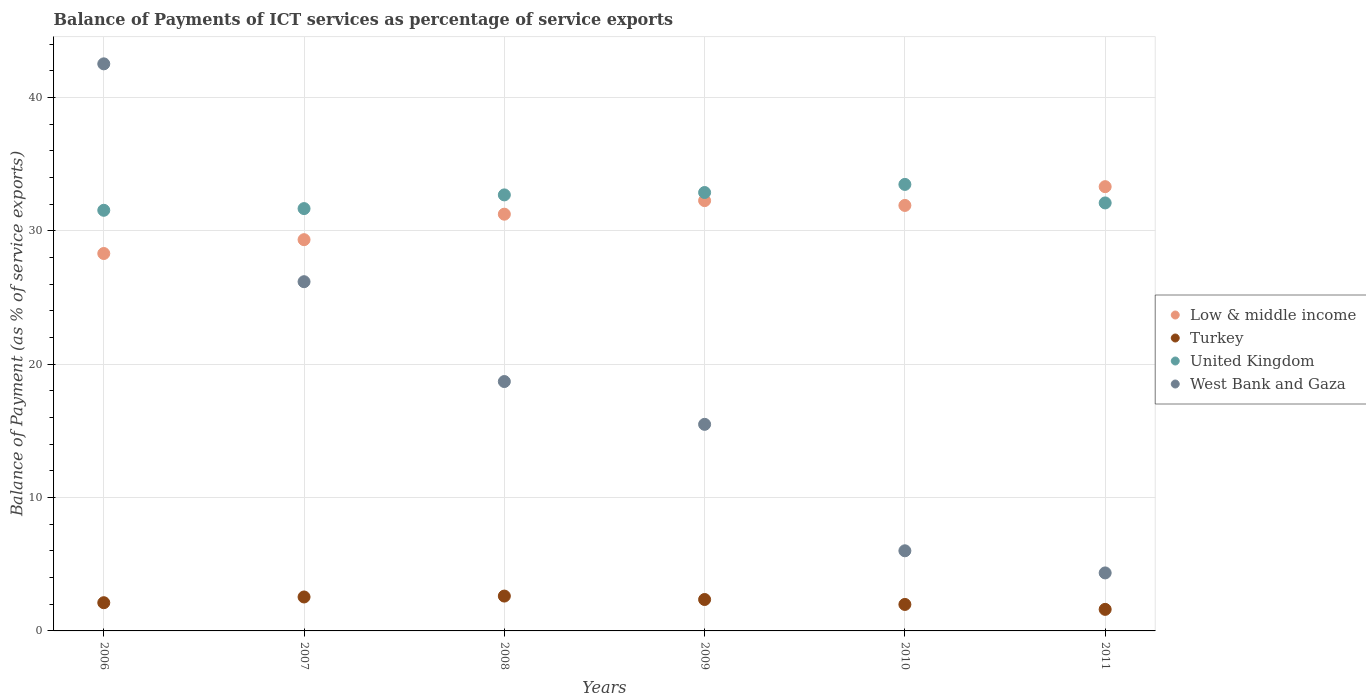Is the number of dotlines equal to the number of legend labels?
Ensure brevity in your answer.  Yes. What is the balance of payments of ICT services in Low & middle income in 2006?
Keep it short and to the point. 28.31. Across all years, what is the maximum balance of payments of ICT services in Turkey?
Your response must be concise. 2.61. Across all years, what is the minimum balance of payments of ICT services in West Bank and Gaza?
Provide a succinct answer. 4.35. In which year was the balance of payments of ICT services in Low & middle income minimum?
Give a very brief answer. 2006. What is the total balance of payments of ICT services in United Kingdom in the graph?
Provide a succinct answer. 194.4. What is the difference between the balance of payments of ICT services in United Kingdom in 2006 and that in 2008?
Offer a very short reply. -1.15. What is the difference between the balance of payments of ICT services in West Bank and Gaza in 2011 and the balance of payments of ICT services in Low & middle income in 2010?
Ensure brevity in your answer.  -27.56. What is the average balance of payments of ICT services in Low & middle income per year?
Provide a short and direct response. 31.07. In the year 2007, what is the difference between the balance of payments of ICT services in Turkey and balance of payments of ICT services in West Bank and Gaza?
Offer a very short reply. -23.65. What is the ratio of the balance of payments of ICT services in United Kingdom in 2010 to that in 2011?
Make the answer very short. 1.04. Is the balance of payments of ICT services in Low & middle income in 2010 less than that in 2011?
Provide a succinct answer. Yes. Is the difference between the balance of payments of ICT services in Turkey in 2008 and 2011 greater than the difference between the balance of payments of ICT services in West Bank and Gaza in 2008 and 2011?
Provide a short and direct response. No. What is the difference between the highest and the second highest balance of payments of ICT services in United Kingdom?
Ensure brevity in your answer.  0.61. What is the difference between the highest and the lowest balance of payments of ICT services in United Kingdom?
Provide a short and direct response. 1.94. Is it the case that in every year, the sum of the balance of payments of ICT services in United Kingdom and balance of payments of ICT services in Low & middle income  is greater than the sum of balance of payments of ICT services in West Bank and Gaza and balance of payments of ICT services in Turkey?
Your response must be concise. Yes. Is it the case that in every year, the sum of the balance of payments of ICT services in West Bank and Gaza and balance of payments of ICT services in Turkey  is greater than the balance of payments of ICT services in Low & middle income?
Make the answer very short. No. Is the balance of payments of ICT services in West Bank and Gaza strictly greater than the balance of payments of ICT services in Low & middle income over the years?
Give a very brief answer. No. How many dotlines are there?
Provide a succinct answer. 4. What is the difference between two consecutive major ticks on the Y-axis?
Offer a very short reply. 10. Are the values on the major ticks of Y-axis written in scientific E-notation?
Your answer should be very brief. No. Does the graph contain any zero values?
Offer a terse response. No. Does the graph contain grids?
Make the answer very short. Yes. Where does the legend appear in the graph?
Your answer should be compact. Center right. How many legend labels are there?
Ensure brevity in your answer.  4. How are the legend labels stacked?
Offer a very short reply. Vertical. What is the title of the graph?
Your response must be concise. Balance of Payments of ICT services as percentage of service exports. What is the label or title of the Y-axis?
Offer a very short reply. Balance of Payment (as % of service exports). What is the Balance of Payment (as % of service exports) of Low & middle income in 2006?
Provide a succinct answer. 28.31. What is the Balance of Payment (as % of service exports) in Turkey in 2006?
Your answer should be very brief. 2.12. What is the Balance of Payment (as % of service exports) of United Kingdom in 2006?
Provide a succinct answer. 31.55. What is the Balance of Payment (as % of service exports) in West Bank and Gaza in 2006?
Provide a short and direct response. 42.53. What is the Balance of Payment (as % of service exports) in Low & middle income in 2007?
Your answer should be compact. 29.34. What is the Balance of Payment (as % of service exports) in Turkey in 2007?
Provide a succinct answer. 2.55. What is the Balance of Payment (as % of service exports) of United Kingdom in 2007?
Give a very brief answer. 31.68. What is the Balance of Payment (as % of service exports) of West Bank and Gaza in 2007?
Give a very brief answer. 26.19. What is the Balance of Payment (as % of service exports) in Low & middle income in 2008?
Your answer should be very brief. 31.26. What is the Balance of Payment (as % of service exports) in Turkey in 2008?
Make the answer very short. 2.61. What is the Balance of Payment (as % of service exports) in United Kingdom in 2008?
Make the answer very short. 32.7. What is the Balance of Payment (as % of service exports) in West Bank and Gaza in 2008?
Make the answer very short. 18.7. What is the Balance of Payment (as % of service exports) in Low & middle income in 2009?
Offer a terse response. 32.27. What is the Balance of Payment (as % of service exports) in Turkey in 2009?
Keep it short and to the point. 2.36. What is the Balance of Payment (as % of service exports) in United Kingdom in 2009?
Your answer should be very brief. 32.88. What is the Balance of Payment (as % of service exports) of West Bank and Gaza in 2009?
Ensure brevity in your answer.  15.49. What is the Balance of Payment (as % of service exports) of Low & middle income in 2010?
Offer a very short reply. 31.91. What is the Balance of Payment (as % of service exports) of Turkey in 2010?
Give a very brief answer. 1.99. What is the Balance of Payment (as % of service exports) of United Kingdom in 2010?
Provide a succinct answer. 33.49. What is the Balance of Payment (as % of service exports) of West Bank and Gaza in 2010?
Your response must be concise. 6.01. What is the Balance of Payment (as % of service exports) in Low & middle income in 2011?
Provide a short and direct response. 33.32. What is the Balance of Payment (as % of service exports) in Turkey in 2011?
Ensure brevity in your answer.  1.62. What is the Balance of Payment (as % of service exports) of United Kingdom in 2011?
Provide a short and direct response. 32.1. What is the Balance of Payment (as % of service exports) of West Bank and Gaza in 2011?
Keep it short and to the point. 4.35. Across all years, what is the maximum Balance of Payment (as % of service exports) in Low & middle income?
Make the answer very short. 33.32. Across all years, what is the maximum Balance of Payment (as % of service exports) in Turkey?
Your answer should be very brief. 2.61. Across all years, what is the maximum Balance of Payment (as % of service exports) in United Kingdom?
Your answer should be compact. 33.49. Across all years, what is the maximum Balance of Payment (as % of service exports) in West Bank and Gaza?
Make the answer very short. 42.53. Across all years, what is the minimum Balance of Payment (as % of service exports) of Low & middle income?
Your answer should be very brief. 28.31. Across all years, what is the minimum Balance of Payment (as % of service exports) of Turkey?
Provide a short and direct response. 1.62. Across all years, what is the minimum Balance of Payment (as % of service exports) in United Kingdom?
Your response must be concise. 31.55. Across all years, what is the minimum Balance of Payment (as % of service exports) of West Bank and Gaza?
Offer a terse response. 4.35. What is the total Balance of Payment (as % of service exports) of Low & middle income in the graph?
Your response must be concise. 186.41. What is the total Balance of Payment (as % of service exports) in Turkey in the graph?
Your answer should be compact. 13.24. What is the total Balance of Payment (as % of service exports) in United Kingdom in the graph?
Offer a terse response. 194.4. What is the total Balance of Payment (as % of service exports) in West Bank and Gaza in the graph?
Your response must be concise. 113.28. What is the difference between the Balance of Payment (as % of service exports) of Low & middle income in 2006 and that in 2007?
Provide a short and direct response. -1.04. What is the difference between the Balance of Payment (as % of service exports) of Turkey in 2006 and that in 2007?
Ensure brevity in your answer.  -0.43. What is the difference between the Balance of Payment (as % of service exports) in United Kingdom in 2006 and that in 2007?
Offer a terse response. -0.13. What is the difference between the Balance of Payment (as % of service exports) in West Bank and Gaza in 2006 and that in 2007?
Offer a terse response. 16.34. What is the difference between the Balance of Payment (as % of service exports) of Low & middle income in 2006 and that in 2008?
Provide a short and direct response. -2.95. What is the difference between the Balance of Payment (as % of service exports) of Turkey in 2006 and that in 2008?
Your answer should be very brief. -0.5. What is the difference between the Balance of Payment (as % of service exports) of United Kingdom in 2006 and that in 2008?
Give a very brief answer. -1.16. What is the difference between the Balance of Payment (as % of service exports) of West Bank and Gaza in 2006 and that in 2008?
Your response must be concise. 23.83. What is the difference between the Balance of Payment (as % of service exports) in Low & middle income in 2006 and that in 2009?
Provide a short and direct response. -3.97. What is the difference between the Balance of Payment (as % of service exports) in Turkey in 2006 and that in 2009?
Your answer should be compact. -0.24. What is the difference between the Balance of Payment (as % of service exports) of United Kingdom in 2006 and that in 2009?
Offer a very short reply. -1.33. What is the difference between the Balance of Payment (as % of service exports) in West Bank and Gaza in 2006 and that in 2009?
Your response must be concise. 27.04. What is the difference between the Balance of Payment (as % of service exports) in Low & middle income in 2006 and that in 2010?
Provide a succinct answer. -3.61. What is the difference between the Balance of Payment (as % of service exports) in Turkey in 2006 and that in 2010?
Ensure brevity in your answer.  0.13. What is the difference between the Balance of Payment (as % of service exports) in United Kingdom in 2006 and that in 2010?
Your answer should be very brief. -1.94. What is the difference between the Balance of Payment (as % of service exports) of West Bank and Gaza in 2006 and that in 2010?
Your response must be concise. 36.52. What is the difference between the Balance of Payment (as % of service exports) in Low & middle income in 2006 and that in 2011?
Offer a very short reply. -5.01. What is the difference between the Balance of Payment (as % of service exports) in Turkey in 2006 and that in 2011?
Your response must be concise. 0.5. What is the difference between the Balance of Payment (as % of service exports) in United Kingdom in 2006 and that in 2011?
Keep it short and to the point. -0.55. What is the difference between the Balance of Payment (as % of service exports) in West Bank and Gaza in 2006 and that in 2011?
Keep it short and to the point. 38.18. What is the difference between the Balance of Payment (as % of service exports) in Low & middle income in 2007 and that in 2008?
Offer a terse response. -1.91. What is the difference between the Balance of Payment (as % of service exports) of Turkey in 2007 and that in 2008?
Keep it short and to the point. -0.07. What is the difference between the Balance of Payment (as % of service exports) in United Kingdom in 2007 and that in 2008?
Provide a succinct answer. -1.03. What is the difference between the Balance of Payment (as % of service exports) of West Bank and Gaza in 2007 and that in 2008?
Provide a succinct answer. 7.49. What is the difference between the Balance of Payment (as % of service exports) in Low & middle income in 2007 and that in 2009?
Make the answer very short. -2.93. What is the difference between the Balance of Payment (as % of service exports) of Turkey in 2007 and that in 2009?
Ensure brevity in your answer.  0.19. What is the difference between the Balance of Payment (as % of service exports) of United Kingdom in 2007 and that in 2009?
Your answer should be very brief. -1.21. What is the difference between the Balance of Payment (as % of service exports) in West Bank and Gaza in 2007 and that in 2009?
Provide a short and direct response. 10.7. What is the difference between the Balance of Payment (as % of service exports) of Low & middle income in 2007 and that in 2010?
Ensure brevity in your answer.  -2.57. What is the difference between the Balance of Payment (as % of service exports) of Turkey in 2007 and that in 2010?
Your answer should be very brief. 0.56. What is the difference between the Balance of Payment (as % of service exports) of United Kingdom in 2007 and that in 2010?
Your response must be concise. -1.81. What is the difference between the Balance of Payment (as % of service exports) in West Bank and Gaza in 2007 and that in 2010?
Your response must be concise. 20.18. What is the difference between the Balance of Payment (as % of service exports) of Low & middle income in 2007 and that in 2011?
Your answer should be compact. -3.98. What is the difference between the Balance of Payment (as % of service exports) in Turkey in 2007 and that in 2011?
Offer a very short reply. 0.93. What is the difference between the Balance of Payment (as % of service exports) of United Kingdom in 2007 and that in 2011?
Ensure brevity in your answer.  -0.42. What is the difference between the Balance of Payment (as % of service exports) in West Bank and Gaza in 2007 and that in 2011?
Provide a short and direct response. 21.84. What is the difference between the Balance of Payment (as % of service exports) in Low & middle income in 2008 and that in 2009?
Your answer should be very brief. -1.02. What is the difference between the Balance of Payment (as % of service exports) in Turkey in 2008 and that in 2009?
Offer a very short reply. 0.26. What is the difference between the Balance of Payment (as % of service exports) in United Kingdom in 2008 and that in 2009?
Offer a very short reply. -0.18. What is the difference between the Balance of Payment (as % of service exports) in West Bank and Gaza in 2008 and that in 2009?
Your answer should be compact. 3.21. What is the difference between the Balance of Payment (as % of service exports) in Low & middle income in 2008 and that in 2010?
Provide a short and direct response. -0.66. What is the difference between the Balance of Payment (as % of service exports) of Turkey in 2008 and that in 2010?
Your answer should be compact. 0.63. What is the difference between the Balance of Payment (as % of service exports) in United Kingdom in 2008 and that in 2010?
Offer a terse response. -0.79. What is the difference between the Balance of Payment (as % of service exports) in West Bank and Gaza in 2008 and that in 2010?
Make the answer very short. 12.69. What is the difference between the Balance of Payment (as % of service exports) of Low & middle income in 2008 and that in 2011?
Make the answer very short. -2.06. What is the difference between the Balance of Payment (as % of service exports) in Turkey in 2008 and that in 2011?
Keep it short and to the point. 1. What is the difference between the Balance of Payment (as % of service exports) of United Kingdom in 2008 and that in 2011?
Provide a succinct answer. 0.6. What is the difference between the Balance of Payment (as % of service exports) in West Bank and Gaza in 2008 and that in 2011?
Your response must be concise. 14.35. What is the difference between the Balance of Payment (as % of service exports) of Low & middle income in 2009 and that in 2010?
Keep it short and to the point. 0.36. What is the difference between the Balance of Payment (as % of service exports) in Turkey in 2009 and that in 2010?
Ensure brevity in your answer.  0.37. What is the difference between the Balance of Payment (as % of service exports) of United Kingdom in 2009 and that in 2010?
Offer a terse response. -0.61. What is the difference between the Balance of Payment (as % of service exports) of West Bank and Gaza in 2009 and that in 2010?
Provide a succinct answer. 9.48. What is the difference between the Balance of Payment (as % of service exports) of Low & middle income in 2009 and that in 2011?
Your answer should be very brief. -1.05. What is the difference between the Balance of Payment (as % of service exports) in Turkey in 2009 and that in 2011?
Provide a short and direct response. 0.74. What is the difference between the Balance of Payment (as % of service exports) in United Kingdom in 2009 and that in 2011?
Provide a succinct answer. 0.78. What is the difference between the Balance of Payment (as % of service exports) in West Bank and Gaza in 2009 and that in 2011?
Offer a very short reply. 11.14. What is the difference between the Balance of Payment (as % of service exports) in Low & middle income in 2010 and that in 2011?
Your answer should be compact. -1.41. What is the difference between the Balance of Payment (as % of service exports) in Turkey in 2010 and that in 2011?
Your answer should be very brief. 0.37. What is the difference between the Balance of Payment (as % of service exports) of United Kingdom in 2010 and that in 2011?
Ensure brevity in your answer.  1.39. What is the difference between the Balance of Payment (as % of service exports) in West Bank and Gaza in 2010 and that in 2011?
Provide a succinct answer. 1.66. What is the difference between the Balance of Payment (as % of service exports) in Low & middle income in 2006 and the Balance of Payment (as % of service exports) in Turkey in 2007?
Provide a short and direct response. 25.76. What is the difference between the Balance of Payment (as % of service exports) of Low & middle income in 2006 and the Balance of Payment (as % of service exports) of United Kingdom in 2007?
Provide a succinct answer. -3.37. What is the difference between the Balance of Payment (as % of service exports) of Low & middle income in 2006 and the Balance of Payment (as % of service exports) of West Bank and Gaza in 2007?
Your response must be concise. 2.11. What is the difference between the Balance of Payment (as % of service exports) in Turkey in 2006 and the Balance of Payment (as % of service exports) in United Kingdom in 2007?
Make the answer very short. -29.56. What is the difference between the Balance of Payment (as % of service exports) of Turkey in 2006 and the Balance of Payment (as % of service exports) of West Bank and Gaza in 2007?
Your answer should be very brief. -24.08. What is the difference between the Balance of Payment (as % of service exports) of United Kingdom in 2006 and the Balance of Payment (as % of service exports) of West Bank and Gaza in 2007?
Your response must be concise. 5.36. What is the difference between the Balance of Payment (as % of service exports) in Low & middle income in 2006 and the Balance of Payment (as % of service exports) in Turkey in 2008?
Your answer should be compact. 25.69. What is the difference between the Balance of Payment (as % of service exports) of Low & middle income in 2006 and the Balance of Payment (as % of service exports) of United Kingdom in 2008?
Your answer should be very brief. -4.4. What is the difference between the Balance of Payment (as % of service exports) of Low & middle income in 2006 and the Balance of Payment (as % of service exports) of West Bank and Gaza in 2008?
Provide a short and direct response. 9.6. What is the difference between the Balance of Payment (as % of service exports) in Turkey in 2006 and the Balance of Payment (as % of service exports) in United Kingdom in 2008?
Provide a succinct answer. -30.59. What is the difference between the Balance of Payment (as % of service exports) in Turkey in 2006 and the Balance of Payment (as % of service exports) in West Bank and Gaza in 2008?
Offer a terse response. -16.59. What is the difference between the Balance of Payment (as % of service exports) in United Kingdom in 2006 and the Balance of Payment (as % of service exports) in West Bank and Gaza in 2008?
Give a very brief answer. 12.84. What is the difference between the Balance of Payment (as % of service exports) of Low & middle income in 2006 and the Balance of Payment (as % of service exports) of Turkey in 2009?
Give a very brief answer. 25.95. What is the difference between the Balance of Payment (as % of service exports) of Low & middle income in 2006 and the Balance of Payment (as % of service exports) of United Kingdom in 2009?
Make the answer very short. -4.57. What is the difference between the Balance of Payment (as % of service exports) in Low & middle income in 2006 and the Balance of Payment (as % of service exports) in West Bank and Gaza in 2009?
Provide a succinct answer. 12.81. What is the difference between the Balance of Payment (as % of service exports) in Turkey in 2006 and the Balance of Payment (as % of service exports) in United Kingdom in 2009?
Offer a very short reply. -30.77. What is the difference between the Balance of Payment (as % of service exports) in Turkey in 2006 and the Balance of Payment (as % of service exports) in West Bank and Gaza in 2009?
Keep it short and to the point. -13.38. What is the difference between the Balance of Payment (as % of service exports) of United Kingdom in 2006 and the Balance of Payment (as % of service exports) of West Bank and Gaza in 2009?
Give a very brief answer. 16.05. What is the difference between the Balance of Payment (as % of service exports) of Low & middle income in 2006 and the Balance of Payment (as % of service exports) of Turkey in 2010?
Make the answer very short. 26.32. What is the difference between the Balance of Payment (as % of service exports) of Low & middle income in 2006 and the Balance of Payment (as % of service exports) of United Kingdom in 2010?
Give a very brief answer. -5.18. What is the difference between the Balance of Payment (as % of service exports) of Low & middle income in 2006 and the Balance of Payment (as % of service exports) of West Bank and Gaza in 2010?
Ensure brevity in your answer.  22.3. What is the difference between the Balance of Payment (as % of service exports) of Turkey in 2006 and the Balance of Payment (as % of service exports) of United Kingdom in 2010?
Your answer should be very brief. -31.37. What is the difference between the Balance of Payment (as % of service exports) in Turkey in 2006 and the Balance of Payment (as % of service exports) in West Bank and Gaza in 2010?
Offer a terse response. -3.89. What is the difference between the Balance of Payment (as % of service exports) in United Kingdom in 2006 and the Balance of Payment (as % of service exports) in West Bank and Gaza in 2010?
Give a very brief answer. 25.54. What is the difference between the Balance of Payment (as % of service exports) of Low & middle income in 2006 and the Balance of Payment (as % of service exports) of Turkey in 2011?
Keep it short and to the point. 26.69. What is the difference between the Balance of Payment (as % of service exports) of Low & middle income in 2006 and the Balance of Payment (as % of service exports) of United Kingdom in 2011?
Your answer should be compact. -3.79. What is the difference between the Balance of Payment (as % of service exports) of Low & middle income in 2006 and the Balance of Payment (as % of service exports) of West Bank and Gaza in 2011?
Keep it short and to the point. 23.96. What is the difference between the Balance of Payment (as % of service exports) in Turkey in 2006 and the Balance of Payment (as % of service exports) in United Kingdom in 2011?
Make the answer very short. -29.98. What is the difference between the Balance of Payment (as % of service exports) in Turkey in 2006 and the Balance of Payment (as % of service exports) in West Bank and Gaza in 2011?
Keep it short and to the point. -2.23. What is the difference between the Balance of Payment (as % of service exports) in United Kingdom in 2006 and the Balance of Payment (as % of service exports) in West Bank and Gaza in 2011?
Offer a terse response. 27.2. What is the difference between the Balance of Payment (as % of service exports) of Low & middle income in 2007 and the Balance of Payment (as % of service exports) of Turkey in 2008?
Offer a very short reply. 26.73. What is the difference between the Balance of Payment (as % of service exports) of Low & middle income in 2007 and the Balance of Payment (as % of service exports) of United Kingdom in 2008?
Offer a terse response. -3.36. What is the difference between the Balance of Payment (as % of service exports) in Low & middle income in 2007 and the Balance of Payment (as % of service exports) in West Bank and Gaza in 2008?
Give a very brief answer. 10.64. What is the difference between the Balance of Payment (as % of service exports) of Turkey in 2007 and the Balance of Payment (as % of service exports) of United Kingdom in 2008?
Ensure brevity in your answer.  -30.16. What is the difference between the Balance of Payment (as % of service exports) of Turkey in 2007 and the Balance of Payment (as % of service exports) of West Bank and Gaza in 2008?
Provide a short and direct response. -16.16. What is the difference between the Balance of Payment (as % of service exports) in United Kingdom in 2007 and the Balance of Payment (as % of service exports) in West Bank and Gaza in 2008?
Make the answer very short. 12.97. What is the difference between the Balance of Payment (as % of service exports) of Low & middle income in 2007 and the Balance of Payment (as % of service exports) of Turkey in 2009?
Offer a very short reply. 26.99. What is the difference between the Balance of Payment (as % of service exports) of Low & middle income in 2007 and the Balance of Payment (as % of service exports) of United Kingdom in 2009?
Your answer should be very brief. -3.54. What is the difference between the Balance of Payment (as % of service exports) in Low & middle income in 2007 and the Balance of Payment (as % of service exports) in West Bank and Gaza in 2009?
Your response must be concise. 13.85. What is the difference between the Balance of Payment (as % of service exports) in Turkey in 2007 and the Balance of Payment (as % of service exports) in United Kingdom in 2009?
Your answer should be very brief. -30.34. What is the difference between the Balance of Payment (as % of service exports) in Turkey in 2007 and the Balance of Payment (as % of service exports) in West Bank and Gaza in 2009?
Your answer should be very brief. -12.95. What is the difference between the Balance of Payment (as % of service exports) in United Kingdom in 2007 and the Balance of Payment (as % of service exports) in West Bank and Gaza in 2009?
Offer a very short reply. 16.18. What is the difference between the Balance of Payment (as % of service exports) in Low & middle income in 2007 and the Balance of Payment (as % of service exports) in Turkey in 2010?
Offer a terse response. 27.36. What is the difference between the Balance of Payment (as % of service exports) of Low & middle income in 2007 and the Balance of Payment (as % of service exports) of United Kingdom in 2010?
Ensure brevity in your answer.  -4.14. What is the difference between the Balance of Payment (as % of service exports) of Low & middle income in 2007 and the Balance of Payment (as % of service exports) of West Bank and Gaza in 2010?
Offer a terse response. 23.33. What is the difference between the Balance of Payment (as % of service exports) of Turkey in 2007 and the Balance of Payment (as % of service exports) of United Kingdom in 2010?
Keep it short and to the point. -30.94. What is the difference between the Balance of Payment (as % of service exports) in Turkey in 2007 and the Balance of Payment (as % of service exports) in West Bank and Gaza in 2010?
Your answer should be very brief. -3.46. What is the difference between the Balance of Payment (as % of service exports) in United Kingdom in 2007 and the Balance of Payment (as % of service exports) in West Bank and Gaza in 2010?
Your response must be concise. 25.67. What is the difference between the Balance of Payment (as % of service exports) of Low & middle income in 2007 and the Balance of Payment (as % of service exports) of Turkey in 2011?
Your answer should be very brief. 27.73. What is the difference between the Balance of Payment (as % of service exports) in Low & middle income in 2007 and the Balance of Payment (as % of service exports) in United Kingdom in 2011?
Offer a terse response. -2.76. What is the difference between the Balance of Payment (as % of service exports) of Low & middle income in 2007 and the Balance of Payment (as % of service exports) of West Bank and Gaza in 2011?
Your response must be concise. 24.99. What is the difference between the Balance of Payment (as % of service exports) in Turkey in 2007 and the Balance of Payment (as % of service exports) in United Kingdom in 2011?
Offer a very short reply. -29.55. What is the difference between the Balance of Payment (as % of service exports) of Turkey in 2007 and the Balance of Payment (as % of service exports) of West Bank and Gaza in 2011?
Make the answer very short. -1.8. What is the difference between the Balance of Payment (as % of service exports) in United Kingdom in 2007 and the Balance of Payment (as % of service exports) in West Bank and Gaza in 2011?
Keep it short and to the point. 27.33. What is the difference between the Balance of Payment (as % of service exports) of Low & middle income in 2008 and the Balance of Payment (as % of service exports) of Turkey in 2009?
Offer a terse response. 28.9. What is the difference between the Balance of Payment (as % of service exports) of Low & middle income in 2008 and the Balance of Payment (as % of service exports) of United Kingdom in 2009?
Offer a very short reply. -1.63. What is the difference between the Balance of Payment (as % of service exports) in Low & middle income in 2008 and the Balance of Payment (as % of service exports) in West Bank and Gaza in 2009?
Give a very brief answer. 15.76. What is the difference between the Balance of Payment (as % of service exports) in Turkey in 2008 and the Balance of Payment (as % of service exports) in United Kingdom in 2009?
Offer a very short reply. -30.27. What is the difference between the Balance of Payment (as % of service exports) in Turkey in 2008 and the Balance of Payment (as % of service exports) in West Bank and Gaza in 2009?
Offer a terse response. -12.88. What is the difference between the Balance of Payment (as % of service exports) in United Kingdom in 2008 and the Balance of Payment (as % of service exports) in West Bank and Gaza in 2009?
Offer a very short reply. 17.21. What is the difference between the Balance of Payment (as % of service exports) in Low & middle income in 2008 and the Balance of Payment (as % of service exports) in Turkey in 2010?
Keep it short and to the point. 29.27. What is the difference between the Balance of Payment (as % of service exports) in Low & middle income in 2008 and the Balance of Payment (as % of service exports) in United Kingdom in 2010?
Provide a short and direct response. -2.23. What is the difference between the Balance of Payment (as % of service exports) in Low & middle income in 2008 and the Balance of Payment (as % of service exports) in West Bank and Gaza in 2010?
Offer a very short reply. 25.25. What is the difference between the Balance of Payment (as % of service exports) in Turkey in 2008 and the Balance of Payment (as % of service exports) in United Kingdom in 2010?
Provide a short and direct response. -30.88. What is the difference between the Balance of Payment (as % of service exports) of Turkey in 2008 and the Balance of Payment (as % of service exports) of West Bank and Gaza in 2010?
Provide a short and direct response. -3.4. What is the difference between the Balance of Payment (as % of service exports) in United Kingdom in 2008 and the Balance of Payment (as % of service exports) in West Bank and Gaza in 2010?
Give a very brief answer. 26.69. What is the difference between the Balance of Payment (as % of service exports) of Low & middle income in 2008 and the Balance of Payment (as % of service exports) of Turkey in 2011?
Your answer should be compact. 29.64. What is the difference between the Balance of Payment (as % of service exports) in Low & middle income in 2008 and the Balance of Payment (as % of service exports) in United Kingdom in 2011?
Your answer should be very brief. -0.84. What is the difference between the Balance of Payment (as % of service exports) in Low & middle income in 2008 and the Balance of Payment (as % of service exports) in West Bank and Gaza in 2011?
Provide a short and direct response. 26.91. What is the difference between the Balance of Payment (as % of service exports) of Turkey in 2008 and the Balance of Payment (as % of service exports) of United Kingdom in 2011?
Offer a terse response. -29.49. What is the difference between the Balance of Payment (as % of service exports) in Turkey in 2008 and the Balance of Payment (as % of service exports) in West Bank and Gaza in 2011?
Offer a terse response. -1.74. What is the difference between the Balance of Payment (as % of service exports) in United Kingdom in 2008 and the Balance of Payment (as % of service exports) in West Bank and Gaza in 2011?
Make the answer very short. 28.35. What is the difference between the Balance of Payment (as % of service exports) in Low & middle income in 2009 and the Balance of Payment (as % of service exports) in Turkey in 2010?
Your answer should be compact. 30.29. What is the difference between the Balance of Payment (as % of service exports) of Low & middle income in 2009 and the Balance of Payment (as % of service exports) of United Kingdom in 2010?
Ensure brevity in your answer.  -1.22. What is the difference between the Balance of Payment (as % of service exports) in Low & middle income in 2009 and the Balance of Payment (as % of service exports) in West Bank and Gaza in 2010?
Ensure brevity in your answer.  26.26. What is the difference between the Balance of Payment (as % of service exports) in Turkey in 2009 and the Balance of Payment (as % of service exports) in United Kingdom in 2010?
Your answer should be compact. -31.13. What is the difference between the Balance of Payment (as % of service exports) in Turkey in 2009 and the Balance of Payment (as % of service exports) in West Bank and Gaza in 2010?
Keep it short and to the point. -3.65. What is the difference between the Balance of Payment (as % of service exports) in United Kingdom in 2009 and the Balance of Payment (as % of service exports) in West Bank and Gaza in 2010?
Keep it short and to the point. 26.87. What is the difference between the Balance of Payment (as % of service exports) of Low & middle income in 2009 and the Balance of Payment (as % of service exports) of Turkey in 2011?
Your answer should be compact. 30.66. What is the difference between the Balance of Payment (as % of service exports) in Low & middle income in 2009 and the Balance of Payment (as % of service exports) in United Kingdom in 2011?
Offer a very short reply. 0.17. What is the difference between the Balance of Payment (as % of service exports) of Low & middle income in 2009 and the Balance of Payment (as % of service exports) of West Bank and Gaza in 2011?
Ensure brevity in your answer.  27.92. What is the difference between the Balance of Payment (as % of service exports) in Turkey in 2009 and the Balance of Payment (as % of service exports) in United Kingdom in 2011?
Keep it short and to the point. -29.74. What is the difference between the Balance of Payment (as % of service exports) in Turkey in 2009 and the Balance of Payment (as % of service exports) in West Bank and Gaza in 2011?
Provide a succinct answer. -1.99. What is the difference between the Balance of Payment (as % of service exports) in United Kingdom in 2009 and the Balance of Payment (as % of service exports) in West Bank and Gaza in 2011?
Offer a terse response. 28.53. What is the difference between the Balance of Payment (as % of service exports) of Low & middle income in 2010 and the Balance of Payment (as % of service exports) of Turkey in 2011?
Your answer should be compact. 30.3. What is the difference between the Balance of Payment (as % of service exports) in Low & middle income in 2010 and the Balance of Payment (as % of service exports) in United Kingdom in 2011?
Your answer should be compact. -0.19. What is the difference between the Balance of Payment (as % of service exports) of Low & middle income in 2010 and the Balance of Payment (as % of service exports) of West Bank and Gaza in 2011?
Your response must be concise. 27.56. What is the difference between the Balance of Payment (as % of service exports) of Turkey in 2010 and the Balance of Payment (as % of service exports) of United Kingdom in 2011?
Offer a very short reply. -30.11. What is the difference between the Balance of Payment (as % of service exports) of Turkey in 2010 and the Balance of Payment (as % of service exports) of West Bank and Gaza in 2011?
Your answer should be very brief. -2.36. What is the difference between the Balance of Payment (as % of service exports) of United Kingdom in 2010 and the Balance of Payment (as % of service exports) of West Bank and Gaza in 2011?
Provide a succinct answer. 29.14. What is the average Balance of Payment (as % of service exports) in Low & middle income per year?
Your response must be concise. 31.07. What is the average Balance of Payment (as % of service exports) in Turkey per year?
Keep it short and to the point. 2.21. What is the average Balance of Payment (as % of service exports) in United Kingdom per year?
Give a very brief answer. 32.4. What is the average Balance of Payment (as % of service exports) in West Bank and Gaza per year?
Ensure brevity in your answer.  18.88. In the year 2006, what is the difference between the Balance of Payment (as % of service exports) of Low & middle income and Balance of Payment (as % of service exports) of Turkey?
Your response must be concise. 26.19. In the year 2006, what is the difference between the Balance of Payment (as % of service exports) in Low & middle income and Balance of Payment (as % of service exports) in United Kingdom?
Your answer should be compact. -3.24. In the year 2006, what is the difference between the Balance of Payment (as % of service exports) of Low & middle income and Balance of Payment (as % of service exports) of West Bank and Gaza?
Make the answer very short. -14.22. In the year 2006, what is the difference between the Balance of Payment (as % of service exports) in Turkey and Balance of Payment (as % of service exports) in United Kingdom?
Provide a succinct answer. -29.43. In the year 2006, what is the difference between the Balance of Payment (as % of service exports) in Turkey and Balance of Payment (as % of service exports) in West Bank and Gaza?
Provide a short and direct response. -40.42. In the year 2006, what is the difference between the Balance of Payment (as % of service exports) in United Kingdom and Balance of Payment (as % of service exports) in West Bank and Gaza?
Your answer should be very brief. -10.98. In the year 2007, what is the difference between the Balance of Payment (as % of service exports) in Low & middle income and Balance of Payment (as % of service exports) in Turkey?
Give a very brief answer. 26.8. In the year 2007, what is the difference between the Balance of Payment (as % of service exports) of Low & middle income and Balance of Payment (as % of service exports) of United Kingdom?
Offer a very short reply. -2.33. In the year 2007, what is the difference between the Balance of Payment (as % of service exports) in Low & middle income and Balance of Payment (as % of service exports) in West Bank and Gaza?
Your response must be concise. 3.15. In the year 2007, what is the difference between the Balance of Payment (as % of service exports) of Turkey and Balance of Payment (as % of service exports) of United Kingdom?
Provide a short and direct response. -29.13. In the year 2007, what is the difference between the Balance of Payment (as % of service exports) of Turkey and Balance of Payment (as % of service exports) of West Bank and Gaza?
Your answer should be compact. -23.65. In the year 2007, what is the difference between the Balance of Payment (as % of service exports) in United Kingdom and Balance of Payment (as % of service exports) in West Bank and Gaza?
Provide a succinct answer. 5.48. In the year 2008, what is the difference between the Balance of Payment (as % of service exports) of Low & middle income and Balance of Payment (as % of service exports) of Turkey?
Provide a succinct answer. 28.64. In the year 2008, what is the difference between the Balance of Payment (as % of service exports) of Low & middle income and Balance of Payment (as % of service exports) of United Kingdom?
Ensure brevity in your answer.  -1.45. In the year 2008, what is the difference between the Balance of Payment (as % of service exports) in Low & middle income and Balance of Payment (as % of service exports) in West Bank and Gaza?
Offer a very short reply. 12.55. In the year 2008, what is the difference between the Balance of Payment (as % of service exports) of Turkey and Balance of Payment (as % of service exports) of United Kingdom?
Make the answer very short. -30.09. In the year 2008, what is the difference between the Balance of Payment (as % of service exports) of Turkey and Balance of Payment (as % of service exports) of West Bank and Gaza?
Provide a succinct answer. -16.09. In the year 2008, what is the difference between the Balance of Payment (as % of service exports) of United Kingdom and Balance of Payment (as % of service exports) of West Bank and Gaza?
Your answer should be compact. 14. In the year 2009, what is the difference between the Balance of Payment (as % of service exports) in Low & middle income and Balance of Payment (as % of service exports) in Turkey?
Keep it short and to the point. 29.92. In the year 2009, what is the difference between the Balance of Payment (as % of service exports) of Low & middle income and Balance of Payment (as % of service exports) of United Kingdom?
Offer a terse response. -0.61. In the year 2009, what is the difference between the Balance of Payment (as % of service exports) in Low & middle income and Balance of Payment (as % of service exports) in West Bank and Gaza?
Keep it short and to the point. 16.78. In the year 2009, what is the difference between the Balance of Payment (as % of service exports) of Turkey and Balance of Payment (as % of service exports) of United Kingdom?
Offer a terse response. -30.52. In the year 2009, what is the difference between the Balance of Payment (as % of service exports) of Turkey and Balance of Payment (as % of service exports) of West Bank and Gaza?
Give a very brief answer. -13.14. In the year 2009, what is the difference between the Balance of Payment (as % of service exports) in United Kingdom and Balance of Payment (as % of service exports) in West Bank and Gaza?
Offer a very short reply. 17.39. In the year 2010, what is the difference between the Balance of Payment (as % of service exports) in Low & middle income and Balance of Payment (as % of service exports) in Turkey?
Offer a terse response. 29.93. In the year 2010, what is the difference between the Balance of Payment (as % of service exports) in Low & middle income and Balance of Payment (as % of service exports) in United Kingdom?
Provide a succinct answer. -1.58. In the year 2010, what is the difference between the Balance of Payment (as % of service exports) of Low & middle income and Balance of Payment (as % of service exports) of West Bank and Gaza?
Provide a succinct answer. 25.9. In the year 2010, what is the difference between the Balance of Payment (as % of service exports) in Turkey and Balance of Payment (as % of service exports) in United Kingdom?
Make the answer very short. -31.5. In the year 2010, what is the difference between the Balance of Payment (as % of service exports) in Turkey and Balance of Payment (as % of service exports) in West Bank and Gaza?
Give a very brief answer. -4.02. In the year 2010, what is the difference between the Balance of Payment (as % of service exports) of United Kingdom and Balance of Payment (as % of service exports) of West Bank and Gaza?
Your answer should be compact. 27.48. In the year 2011, what is the difference between the Balance of Payment (as % of service exports) of Low & middle income and Balance of Payment (as % of service exports) of Turkey?
Ensure brevity in your answer.  31.7. In the year 2011, what is the difference between the Balance of Payment (as % of service exports) in Low & middle income and Balance of Payment (as % of service exports) in United Kingdom?
Offer a terse response. 1.22. In the year 2011, what is the difference between the Balance of Payment (as % of service exports) of Low & middle income and Balance of Payment (as % of service exports) of West Bank and Gaza?
Your answer should be compact. 28.97. In the year 2011, what is the difference between the Balance of Payment (as % of service exports) in Turkey and Balance of Payment (as % of service exports) in United Kingdom?
Your answer should be compact. -30.48. In the year 2011, what is the difference between the Balance of Payment (as % of service exports) of Turkey and Balance of Payment (as % of service exports) of West Bank and Gaza?
Give a very brief answer. -2.73. In the year 2011, what is the difference between the Balance of Payment (as % of service exports) of United Kingdom and Balance of Payment (as % of service exports) of West Bank and Gaza?
Ensure brevity in your answer.  27.75. What is the ratio of the Balance of Payment (as % of service exports) in Low & middle income in 2006 to that in 2007?
Ensure brevity in your answer.  0.96. What is the ratio of the Balance of Payment (as % of service exports) of Turkey in 2006 to that in 2007?
Your answer should be compact. 0.83. What is the ratio of the Balance of Payment (as % of service exports) in West Bank and Gaza in 2006 to that in 2007?
Provide a succinct answer. 1.62. What is the ratio of the Balance of Payment (as % of service exports) of Low & middle income in 2006 to that in 2008?
Your answer should be compact. 0.91. What is the ratio of the Balance of Payment (as % of service exports) in Turkey in 2006 to that in 2008?
Make the answer very short. 0.81. What is the ratio of the Balance of Payment (as % of service exports) of United Kingdom in 2006 to that in 2008?
Your response must be concise. 0.96. What is the ratio of the Balance of Payment (as % of service exports) of West Bank and Gaza in 2006 to that in 2008?
Your response must be concise. 2.27. What is the ratio of the Balance of Payment (as % of service exports) of Low & middle income in 2006 to that in 2009?
Provide a short and direct response. 0.88. What is the ratio of the Balance of Payment (as % of service exports) of Turkey in 2006 to that in 2009?
Your response must be concise. 0.9. What is the ratio of the Balance of Payment (as % of service exports) in United Kingdom in 2006 to that in 2009?
Give a very brief answer. 0.96. What is the ratio of the Balance of Payment (as % of service exports) of West Bank and Gaza in 2006 to that in 2009?
Your answer should be compact. 2.75. What is the ratio of the Balance of Payment (as % of service exports) of Low & middle income in 2006 to that in 2010?
Your answer should be very brief. 0.89. What is the ratio of the Balance of Payment (as % of service exports) of Turkey in 2006 to that in 2010?
Offer a very short reply. 1.07. What is the ratio of the Balance of Payment (as % of service exports) of United Kingdom in 2006 to that in 2010?
Provide a succinct answer. 0.94. What is the ratio of the Balance of Payment (as % of service exports) of West Bank and Gaza in 2006 to that in 2010?
Offer a terse response. 7.08. What is the ratio of the Balance of Payment (as % of service exports) in Low & middle income in 2006 to that in 2011?
Give a very brief answer. 0.85. What is the ratio of the Balance of Payment (as % of service exports) in Turkey in 2006 to that in 2011?
Ensure brevity in your answer.  1.31. What is the ratio of the Balance of Payment (as % of service exports) in United Kingdom in 2006 to that in 2011?
Give a very brief answer. 0.98. What is the ratio of the Balance of Payment (as % of service exports) in West Bank and Gaza in 2006 to that in 2011?
Provide a succinct answer. 9.78. What is the ratio of the Balance of Payment (as % of service exports) of Low & middle income in 2007 to that in 2008?
Ensure brevity in your answer.  0.94. What is the ratio of the Balance of Payment (as % of service exports) of Turkey in 2007 to that in 2008?
Make the answer very short. 0.97. What is the ratio of the Balance of Payment (as % of service exports) of United Kingdom in 2007 to that in 2008?
Your answer should be very brief. 0.97. What is the ratio of the Balance of Payment (as % of service exports) in West Bank and Gaza in 2007 to that in 2008?
Make the answer very short. 1.4. What is the ratio of the Balance of Payment (as % of service exports) of Low & middle income in 2007 to that in 2009?
Your answer should be compact. 0.91. What is the ratio of the Balance of Payment (as % of service exports) in Turkey in 2007 to that in 2009?
Ensure brevity in your answer.  1.08. What is the ratio of the Balance of Payment (as % of service exports) of United Kingdom in 2007 to that in 2009?
Your answer should be very brief. 0.96. What is the ratio of the Balance of Payment (as % of service exports) of West Bank and Gaza in 2007 to that in 2009?
Your response must be concise. 1.69. What is the ratio of the Balance of Payment (as % of service exports) in Low & middle income in 2007 to that in 2010?
Give a very brief answer. 0.92. What is the ratio of the Balance of Payment (as % of service exports) in Turkey in 2007 to that in 2010?
Make the answer very short. 1.28. What is the ratio of the Balance of Payment (as % of service exports) in United Kingdom in 2007 to that in 2010?
Your answer should be very brief. 0.95. What is the ratio of the Balance of Payment (as % of service exports) of West Bank and Gaza in 2007 to that in 2010?
Your answer should be very brief. 4.36. What is the ratio of the Balance of Payment (as % of service exports) of Low & middle income in 2007 to that in 2011?
Provide a short and direct response. 0.88. What is the ratio of the Balance of Payment (as % of service exports) in Turkey in 2007 to that in 2011?
Offer a terse response. 1.58. What is the ratio of the Balance of Payment (as % of service exports) of West Bank and Gaza in 2007 to that in 2011?
Give a very brief answer. 6.02. What is the ratio of the Balance of Payment (as % of service exports) of Low & middle income in 2008 to that in 2009?
Give a very brief answer. 0.97. What is the ratio of the Balance of Payment (as % of service exports) in Turkey in 2008 to that in 2009?
Ensure brevity in your answer.  1.11. What is the ratio of the Balance of Payment (as % of service exports) in United Kingdom in 2008 to that in 2009?
Provide a succinct answer. 0.99. What is the ratio of the Balance of Payment (as % of service exports) in West Bank and Gaza in 2008 to that in 2009?
Your answer should be compact. 1.21. What is the ratio of the Balance of Payment (as % of service exports) of Low & middle income in 2008 to that in 2010?
Provide a succinct answer. 0.98. What is the ratio of the Balance of Payment (as % of service exports) of Turkey in 2008 to that in 2010?
Your response must be concise. 1.32. What is the ratio of the Balance of Payment (as % of service exports) in United Kingdom in 2008 to that in 2010?
Give a very brief answer. 0.98. What is the ratio of the Balance of Payment (as % of service exports) of West Bank and Gaza in 2008 to that in 2010?
Offer a terse response. 3.11. What is the ratio of the Balance of Payment (as % of service exports) in Low & middle income in 2008 to that in 2011?
Provide a succinct answer. 0.94. What is the ratio of the Balance of Payment (as % of service exports) of Turkey in 2008 to that in 2011?
Your answer should be compact. 1.62. What is the ratio of the Balance of Payment (as % of service exports) of United Kingdom in 2008 to that in 2011?
Provide a short and direct response. 1.02. What is the ratio of the Balance of Payment (as % of service exports) of West Bank and Gaza in 2008 to that in 2011?
Offer a terse response. 4.3. What is the ratio of the Balance of Payment (as % of service exports) of Low & middle income in 2009 to that in 2010?
Your answer should be very brief. 1.01. What is the ratio of the Balance of Payment (as % of service exports) of Turkey in 2009 to that in 2010?
Your response must be concise. 1.19. What is the ratio of the Balance of Payment (as % of service exports) in United Kingdom in 2009 to that in 2010?
Your answer should be very brief. 0.98. What is the ratio of the Balance of Payment (as % of service exports) in West Bank and Gaza in 2009 to that in 2010?
Ensure brevity in your answer.  2.58. What is the ratio of the Balance of Payment (as % of service exports) of Low & middle income in 2009 to that in 2011?
Provide a succinct answer. 0.97. What is the ratio of the Balance of Payment (as % of service exports) of Turkey in 2009 to that in 2011?
Offer a very short reply. 1.46. What is the ratio of the Balance of Payment (as % of service exports) in United Kingdom in 2009 to that in 2011?
Ensure brevity in your answer.  1.02. What is the ratio of the Balance of Payment (as % of service exports) in West Bank and Gaza in 2009 to that in 2011?
Your answer should be very brief. 3.56. What is the ratio of the Balance of Payment (as % of service exports) in Low & middle income in 2010 to that in 2011?
Give a very brief answer. 0.96. What is the ratio of the Balance of Payment (as % of service exports) of Turkey in 2010 to that in 2011?
Your answer should be very brief. 1.23. What is the ratio of the Balance of Payment (as % of service exports) in United Kingdom in 2010 to that in 2011?
Offer a very short reply. 1.04. What is the ratio of the Balance of Payment (as % of service exports) of West Bank and Gaza in 2010 to that in 2011?
Your answer should be very brief. 1.38. What is the difference between the highest and the second highest Balance of Payment (as % of service exports) of Low & middle income?
Keep it short and to the point. 1.05. What is the difference between the highest and the second highest Balance of Payment (as % of service exports) in Turkey?
Keep it short and to the point. 0.07. What is the difference between the highest and the second highest Balance of Payment (as % of service exports) of United Kingdom?
Provide a succinct answer. 0.61. What is the difference between the highest and the second highest Balance of Payment (as % of service exports) of West Bank and Gaza?
Your response must be concise. 16.34. What is the difference between the highest and the lowest Balance of Payment (as % of service exports) in Low & middle income?
Keep it short and to the point. 5.01. What is the difference between the highest and the lowest Balance of Payment (as % of service exports) of United Kingdom?
Give a very brief answer. 1.94. What is the difference between the highest and the lowest Balance of Payment (as % of service exports) in West Bank and Gaza?
Ensure brevity in your answer.  38.18. 